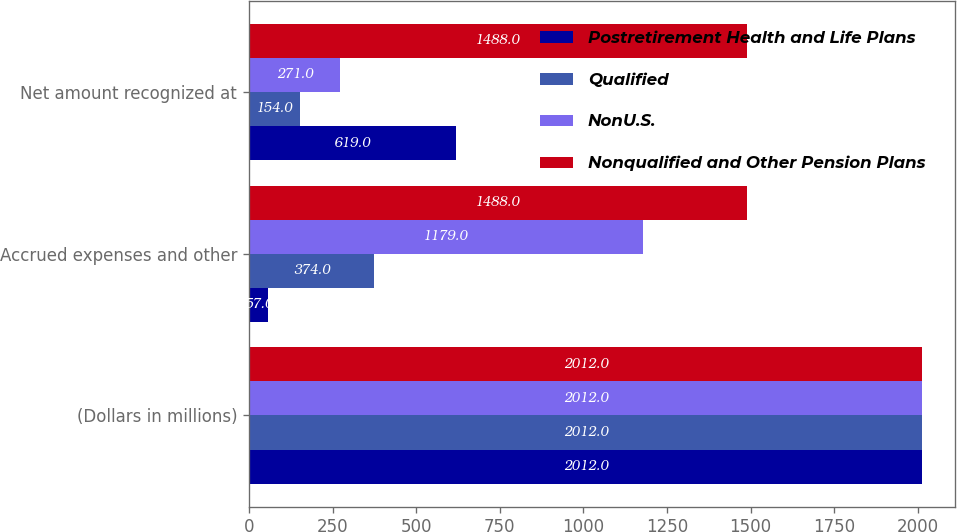<chart> <loc_0><loc_0><loc_500><loc_500><stacked_bar_chart><ecel><fcel>(Dollars in millions)<fcel>Accrued expenses and other<fcel>Net amount recognized at<nl><fcel>Postretirement Health and Life Plans<fcel>2012<fcel>57<fcel>619<nl><fcel>Qualified<fcel>2012<fcel>374<fcel>154<nl><fcel>NonU.S.<fcel>2012<fcel>1179<fcel>271<nl><fcel>Nonqualified and Other Pension Plans<fcel>2012<fcel>1488<fcel>1488<nl></chart> 